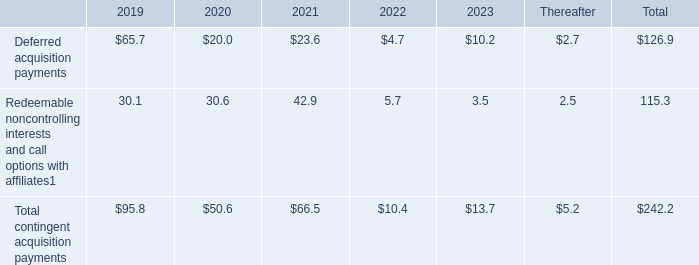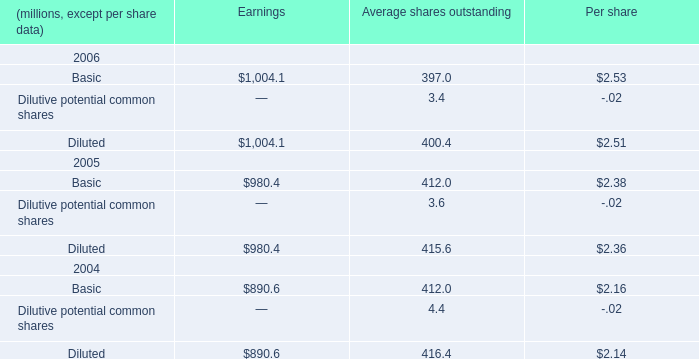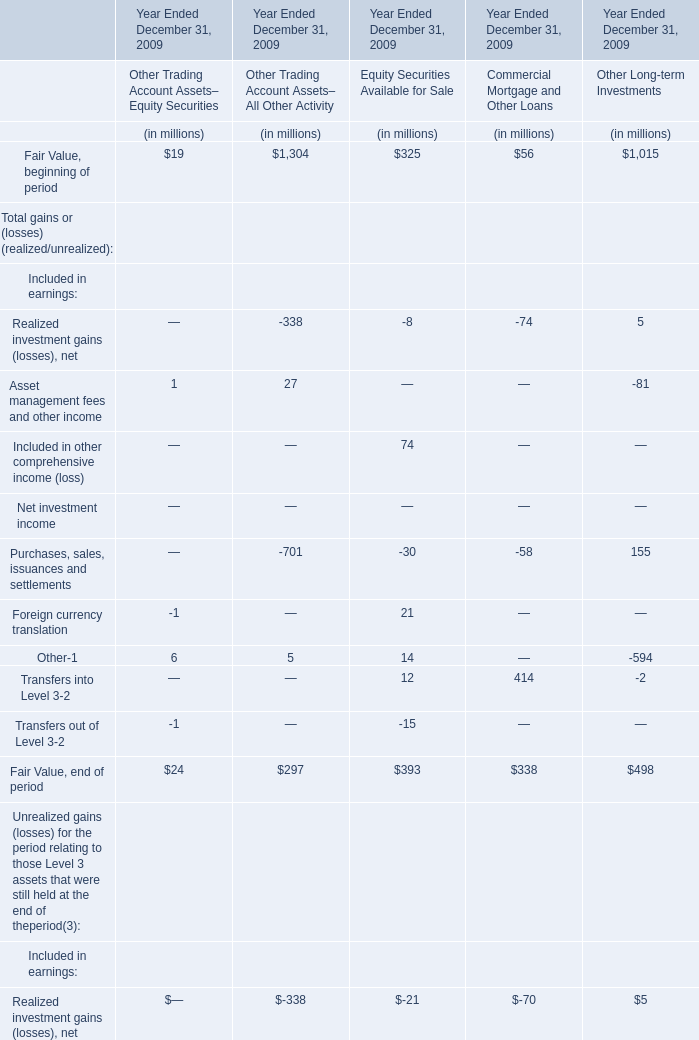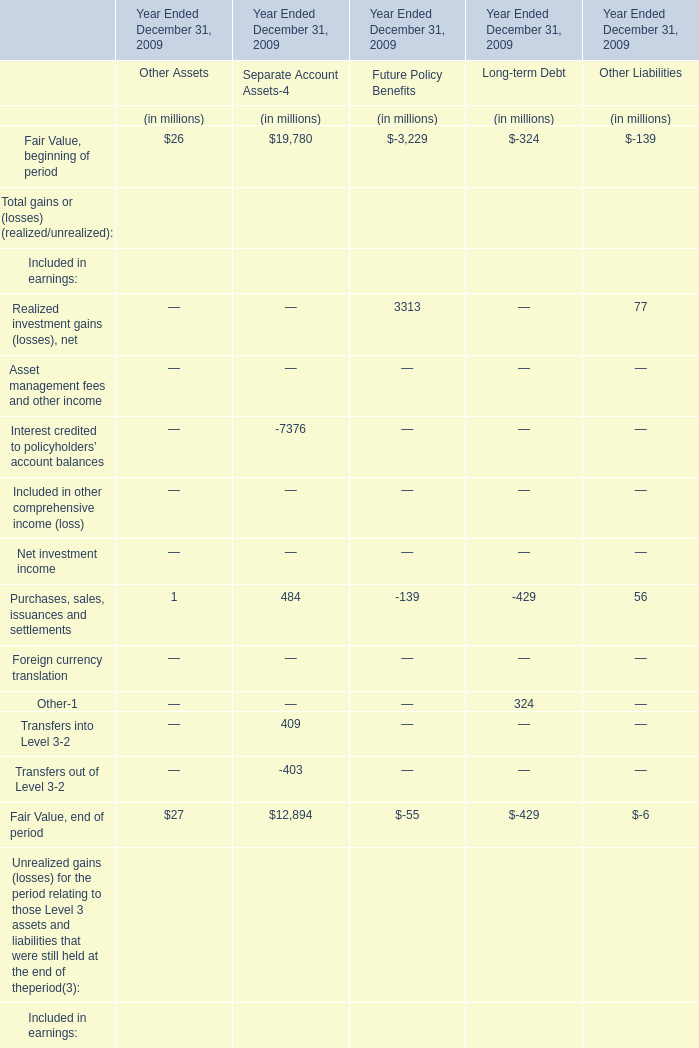What is the Fair Value, beginning of period for Separate Account Assets for Year Ended December 31, 2009? (in million) 
Answer: 19780. 